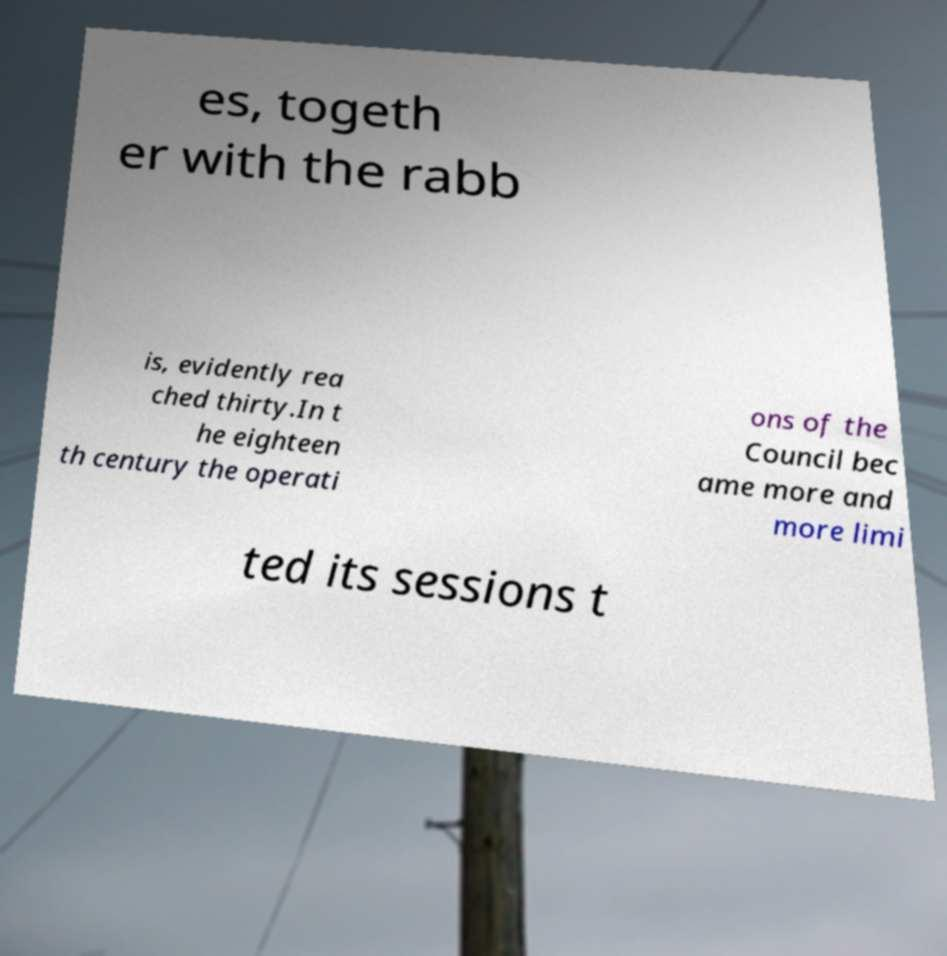There's text embedded in this image that I need extracted. Can you transcribe it verbatim? es, togeth er with the rabb is, evidently rea ched thirty.In t he eighteen th century the operati ons of the Council bec ame more and more limi ted its sessions t 